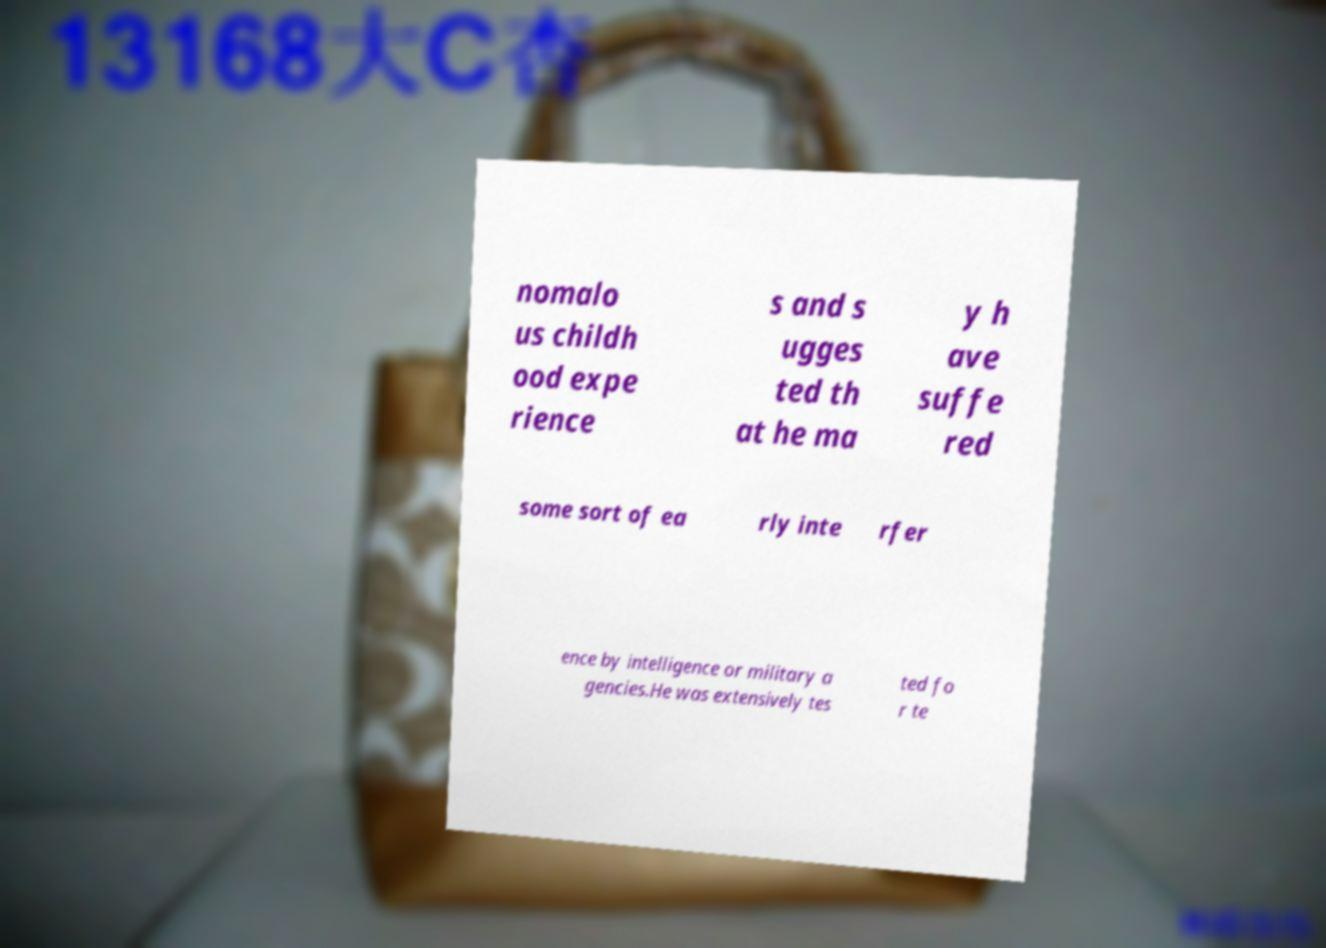There's text embedded in this image that I need extracted. Can you transcribe it verbatim? nomalo us childh ood expe rience s and s ugges ted th at he ma y h ave suffe red some sort of ea rly inte rfer ence by intelligence or military a gencies.He was extensively tes ted fo r te 